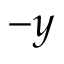Convert formula to latex. <formula><loc_0><loc_0><loc_500><loc_500>- y</formula> 